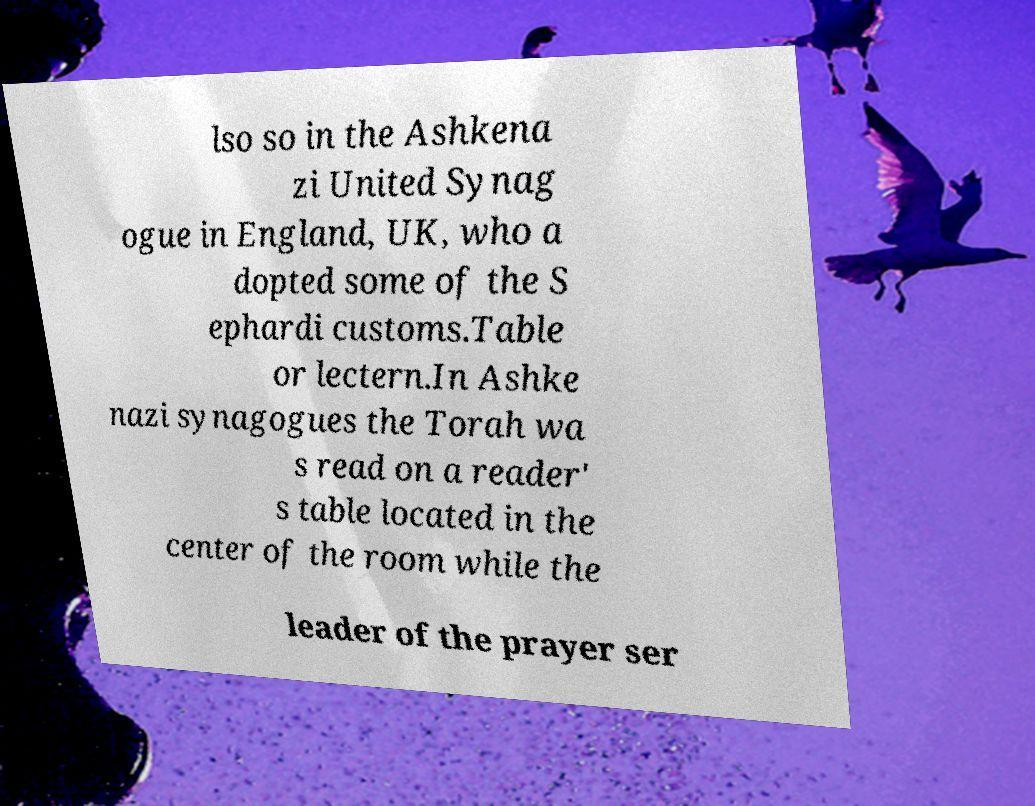Could you assist in decoding the text presented in this image and type it out clearly? lso so in the Ashkena zi United Synag ogue in England, UK, who a dopted some of the S ephardi customs.Table or lectern.In Ashke nazi synagogues the Torah wa s read on a reader' s table located in the center of the room while the leader of the prayer ser 